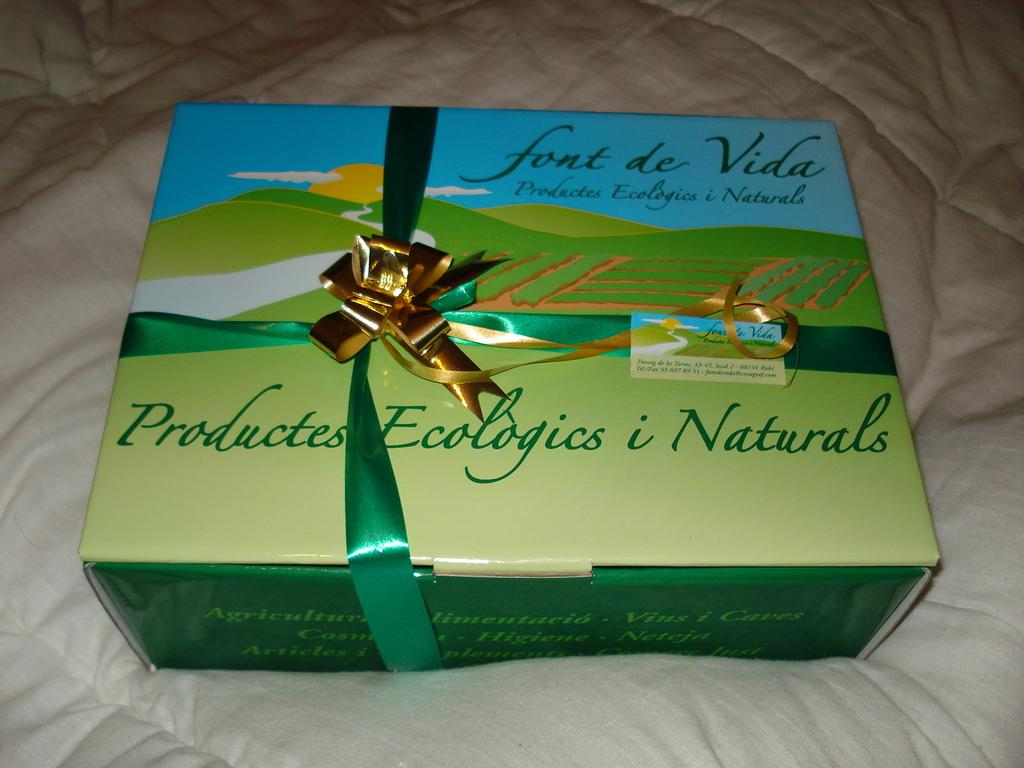Provide a one-sentence caption for the provided image. A box of font de Vida, containing natural products sits on a bed. 